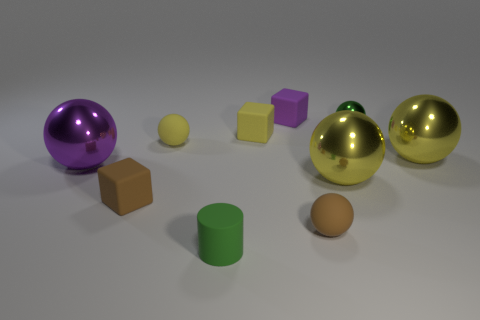What might be the purpose of this collection of objects? This collection of objects could serve various purposes, such as a visual composition for studying light and texture in a 3D rendering software or as a test for color perception and contrast in an artistic setting. 